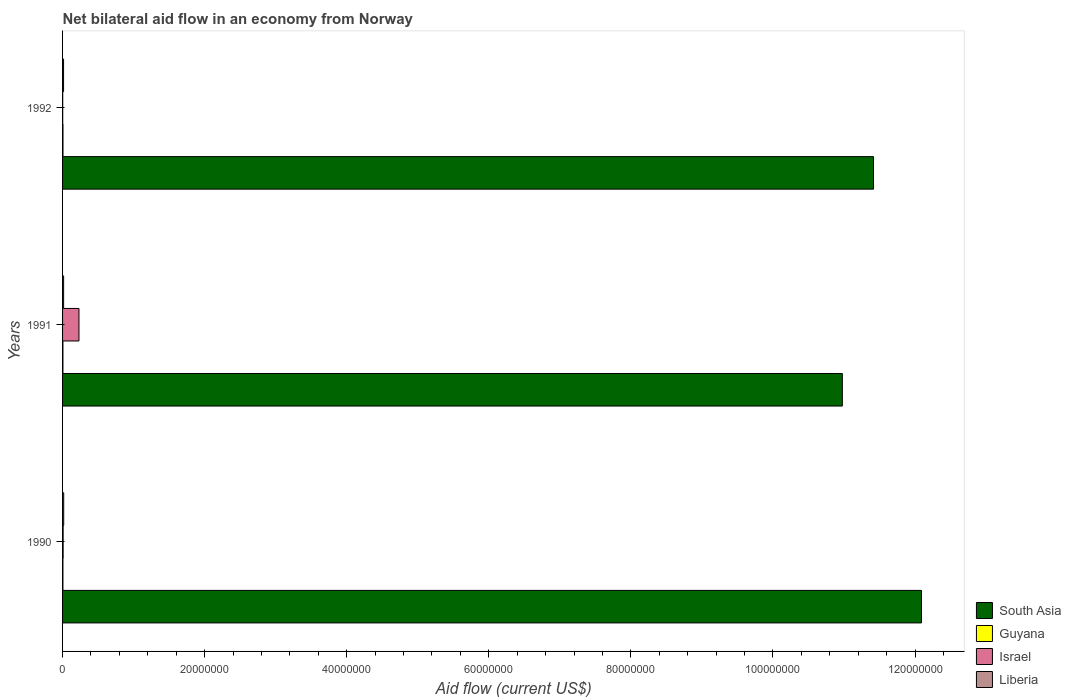How many different coloured bars are there?
Offer a terse response. 4. How many groups of bars are there?
Your response must be concise. 3. Are the number of bars per tick equal to the number of legend labels?
Keep it short and to the point. Yes. How many bars are there on the 1st tick from the top?
Your answer should be compact. 4. How many bars are there on the 2nd tick from the bottom?
Provide a short and direct response. 4. What is the net bilateral aid flow in Guyana in 1992?
Make the answer very short. 6.00e+04. Across all years, what is the minimum net bilateral aid flow in South Asia?
Make the answer very short. 1.10e+08. In which year was the net bilateral aid flow in South Asia minimum?
Your answer should be compact. 1991. What is the total net bilateral aid flow in Liberia in the graph?
Your answer should be very brief. 4.50e+05. What is the difference between the net bilateral aid flow in Liberia in 1990 and that in 1992?
Offer a terse response. 2.00e+04. What is the average net bilateral aid flow in Liberia per year?
Offer a terse response. 1.50e+05. In the year 1991, what is the difference between the net bilateral aid flow in Israel and net bilateral aid flow in Guyana?
Keep it short and to the point. 2.26e+06. Is the net bilateral aid flow in South Asia in 1990 less than that in 1991?
Your answer should be very brief. No. What is the difference between the highest and the lowest net bilateral aid flow in Israel?
Your answer should be very brief. 2.29e+06. In how many years, is the net bilateral aid flow in Israel greater than the average net bilateral aid flow in Israel taken over all years?
Your response must be concise. 1. Is the sum of the net bilateral aid flow in South Asia in 1990 and 1991 greater than the maximum net bilateral aid flow in Guyana across all years?
Keep it short and to the point. Yes. What does the 2nd bar from the top in 1990 represents?
Your answer should be very brief. Israel. What does the 2nd bar from the bottom in 1992 represents?
Your response must be concise. Guyana. Is it the case that in every year, the sum of the net bilateral aid flow in Guyana and net bilateral aid flow in Liberia is greater than the net bilateral aid flow in South Asia?
Make the answer very short. No. How many bars are there?
Your answer should be compact. 12. Are all the bars in the graph horizontal?
Give a very brief answer. Yes. What is the difference between two consecutive major ticks on the X-axis?
Offer a very short reply. 2.00e+07. Does the graph contain any zero values?
Ensure brevity in your answer.  No. Does the graph contain grids?
Your response must be concise. No. Where does the legend appear in the graph?
Offer a terse response. Bottom right. How are the legend labels stacked?
Your answer should be very brief. Vertical. What is the title of the graph?
Give a very brief answer. Net bilateral aid flow in an economy from Norway. Does "Lesotho" appear as one of the legend labels in the graph?
Ensure brevity in your answer.  No. What is the Aid flow (current US$) in South Asia in 1990?
Your response must be concise. 1.21e+08. What is the Aid flow (current US$) of South Asia in 1991?
Give a very brief answer. 1.10e+08. What is the Aid flow (current US$) in Guyana in 1991?
Keep it short and to the point. 5.00e+04. What is the Aid flow (current US$) in Israel in 1991?
Keep it short and to the point. 2.31e+06. What is the Aid flow (current US$) of South Asia in 1992?
Your answer should be very brief. 1.14e+08. What is the Aid flow (current US$) in Guyana in 1992?
Offer a terse response. 6.00e+04. What is the Aid flow (current US$) in Israel in 1992?
Make the answer very short. 2.00e+04. What is the Aid flow (current US$) in Liberia in 1992?
Offer a very short reply. 1.40e+05. Across all years, what is the maximum Aid flow (current US$) in South Asia?
Keep it short and to the point. 1.21e+08. Across all years, what is the maximum Aid flow (current US$) of Guyana?
Your answer should be compact. 6.00e+04. Across all years, what is the maximum Aid flow (current US$) in Israel?
Offer a terse response. 2.31e+06. Across all years, what is the minimum Aid flow (current US$) of South Asia?
Provide a short and direct response. 1.10e+08. Across all years, what is the minimum Aid flow (current US$) of Guyana?
Offer a very short reply. 5.00e+04. What is the total Aid flow (current US$) of South Asia in the graph?
Provide a succinct answer. 3.45e+08. What is the total Aid flow (current US$) of Guyana in the graph?
Keep it short and to the point. 1.60e+05. What is the total Aid flow (current US$) in Israel in the graph?
Provide a succinct answer. 2.41e+06. What is the total Aid flow (current US$) in Liberia in the graph?
Provide a short and direct response. 4.50e+05. What is the difference between the Aid flow (current US$) in South Asia in 1990 and that in 1991?
Make the answer very short. 1.11e+07. What is the difference between the Aid flow (current US$) of Israel in 1990 and that in 1991?
Ensure brevity in your answer.  -2.23e+06. What is the difference between the Aid flow (current US$) of South Asia in 1990 and that in 1992?
Your answer should be compact. 6.75e+06. What is the difference between the Aid flow (current US$) in Guyana in 1990 and that in 1992?
Keep it short and to the point. -10000. What is the difference between the Aid flow (current US$) of Israel in 1990 and that in 1992?
Ensure brevity in your answer.  6.00e+04. What is the difference between the Aid flow (current US$) of Liberia in 1990 and that in 1992?
Give a very brief answer. 2.00e+04. What is the difference between the Aid flow (current US$) in South Asia in 1991 and that in 1992?
Provide a succinct answer. -4.39e+06. What is the difference between the Aid flow (current US$) in Israel in 1991 and that in 1992?
Give a very brief answer. 2.29e+06. What is the difference between the Aid flow (current US$) of South Asia in 1990 and the Aid flow (current US$) of Guyana in 1991?
Your answer should be very brief. 1.21e+08. What is the difference between the Aid flow (current US$) of South Asia in 1990 and the Aid flow (current US$) of Israel in 1991?
Offer a terse response. 1.19e+08. What is the difference between the Aid flow (current US$) of South Asia in 1990 and the Aid flow (current US$) of Liberia in 1991?
Your answer should be compact. 1.21e+08. What is the difference between the Aid flow (current US$) of Guyana in 1990 and the Aid flow (current US$) of Israel in 1991?
Provide a short and direct response. -2.26e+06. What is the difference between the Aid flow (current US$) of South Asia in 1990 and the Aid flow (current US$) of Guyana in 1992?
Make the answer very short. 1.21e+08. What is the difference between the Aid flow (current US$) of South Asia in 1990 and the Aid flow (current US$) of Israel in 1992?
Ensure brevity in your answer.  1.21e+08. What is the difference between the Aid flow (current US$) in South Asia in 1990 and the Aid flow (current US$) in Liberia in 1992?
Give a very brief answer. 1.21e+08. What is the difference between the Aid flow (current US$) of Guyana in 1990 and the Aid flow (current US$) of Israel in 1992?
Provide a succinct answer. 3.00e+04. What is the difference between the Aid flow (current US$) of Guyana in 1990 and the Aid flow (current US$) of Liberia in 1992?
Offer a terse response. -9.00e+04. What is the difference between the Aid flow (current US$) of Israel in 1990 and the Aid flow (current US$) of Liberia in 1992?
Your answer should be very brief. -6.00e+04. What is the difference between the Aid flow (current US$) in South Asia in 1991 and the Aid flow (current US$) in Guyana in 1992?
Offer a very short reply. 1.10e+08. What is the difference between the Aid flow (current US$) of South Asia in 1991 and the Aid flow (current US$) of Israel in 1992?
Offer a terse response. 1.10e+08. What is the difference between the Aid flow (current US$) in South Asia in 1991 and the Aid flow (current US$) in Liberia in 1992?
Provide a succinct answer. 1.10e+08. What is the difference between the Aid flow (current US$) in Guyana in 1991 and the Aid flow (current US$) in Israel in 1992?
Give a very brief answer. 3.00e+04. What is the difference between the Aid flow (current US$) of Guyana in 1991 and the Aid flow (current US$) of Liberia in 1992?
Your answer should be compact. -9.00e+04. What is the difference between the Aid flow (current US$) of Israel in 1991 and the Aid flow (current US$) of Liberia in 1992?
Give a very brief answer. 2.17e+06. What is the average Aid flow (current US$) in South Asia per year?
Provide a succinct answer. 1.15e+08. What is the average Aid flow (current US$) in Guyana per year?
Ensure brevity in your answer.  5.33e+04. What is the average Aid flow (current US$) in Israel per year?
Make the answer very short. 8.03e+05. In the year 1990, what is the difference between the Aid flow (current US$) of South Asia and Aid flow (current US$) of Guyana?
Your response must be concise. 1.21e+08. In the year 1990, what is the difference between the Aid flow (current US$) in South Asia and Aid flow (current US$) in Israel?
Your answer should be very brief. 1.21e+08. In the year 1990, what is the difference between the Aid flow (current US$) in South Asia and Aid flow (current US$) in Liberia?
Provide a succinct answer. 1.21e+08. In the year 1990, what is the difference between the Aid flow (current US$) in Guyana and Aid flow (current US$) in Israel?
Your answer should be very brief. -3.00e+04. In the year 1990, what is the difference between the Aid flow (current US$) of Israel and Aid flow (current US$) of Liberia?
Ensure brevity in your answer.  -8.00e+04. In the year 1991, what is the difference between the Aid flow (current US$) of South Asia and Aid flow (current US$) of Guyana?
Your answer should be compact. 1.10e+08. In the year 1991, what is the difference between the Aid flow (current US$) in South Asia and Aid flow (current US$) in Israel?
Provide a short and direct response. 1.07e+08. In the year 1991, what is the difference between the Aid flow (current US$) in South Asia and Aid flow (current US$) in Liberia?
Give a very brief answer. 1.10e+08. In the year 1991, what is the difference between the Aid flow (current US$) in Guyana and Aid flow (current US$) in Israel?
Ensure brevity in your answer.  -2.26e+06. In the year 1991, what is the difference between the Aid flow (current US$) of Israel and Aid flow (current US$) of Liberia?
Your answer should be very brief. 2.16e+06. In the year 1992, what is the difference between the Aid flow (current US$) of South Asia and Aid flow (current US$) of Guyana?
Your response must be concise. 1.14e+08. In the year 1992, what is the difference between the Aid flow (current US$) in South Asia and Aid flow (current US$) in Israel?
Provide a succinct answer. 1.14e+08. In the year 1992, what is the difference between the Aid flow (current US$) of South Asia and Aid flow (current US$) of Liberia?
Ensure brevity in your answer.  1.14e+08. In the year 1992, what is the difference between the Aid flow (current US$) of Guyana and Aid flow (current US$) of Liberia?
Provide a succinct answer. -8.00e+04. What is the ratio of the Aid flow (current US$) of South Asia in 1990 to that in 1991?
Make the answer very short. 1.1. What is the ratio of the Aid flow (current US$) in Guyana in 1990 to that in 1991?
Keep it short and to the point. 1. What is the ratio of the Aid flow (current US$) in Israel in 1990 to that in 1991?
Keep it short and to the point. 0.03. What is the ratio of the Aid flow (current US$) of Liberia in 1990 to that in 1991?
Keep it short and to the point. 1.07. What is the ratio of the Aid flow (current US$) of South Asia in 1990 to that in 1992?
Provide a short and direct response. 1.06. What is the ratio of the Aid flow (current US$) in Guyana in 1990 to that in 1992?
Give a very brief answer. 0.83. What is the ratio of the Aid flow (current US$) in Israel in 1990 to that in 1992?
Ensure brevity in your answer.  4. What is the ratio of the Aid flow (current US$) of South Asia in 1991 to that in 1992?
Provide a succinct answer. 0.96. What is the ratio of the Aid flow (current US$) of Israel in 1991 to that in 1992?
Make the answer very short. 115.5. What is the ratio of the Aid flow (current US$) in Liberia in 1991 to that in 1992?
Offer a very short reply. 1.07. What is the difference between the highest and the second highest Aid flow (current US$) of South Asia?
Give a very brief answer. 6.75e+06. What is the difference between the highest and the second highest Aid flow (current US$) in Guyana?
Offer a terse response. 10000. What is the difference between the highest and the second highest Aid flow (current US$) in Israel?
Offer a very short reply. 2.23e+06. What is the difference between the highest and the second highest Aid flow (current US$) of Liberia?
Provide a succinct answer. 10000. What is the difference between the highest and the lowest Aid flow (current US$) of South Asia?
Ensure brevity in your answer.  1.11e+07. What is the difference between the highest and the lowest Aid flow (current US$) of Israel?
Give a very brief answer. 2.29e+06. 